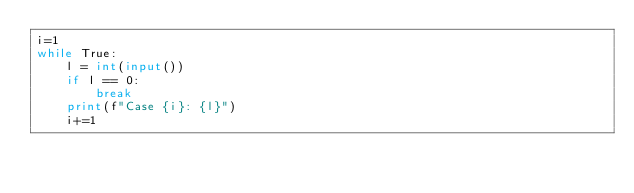Convert code to text. <code><loc_0><loc_0><loc_500><loc_500><_Python_>i=1
while True:
    l = int(input())
    if l == 0:
        break
    print(f"Case {i}: {l}")
    i+=1
</code> 